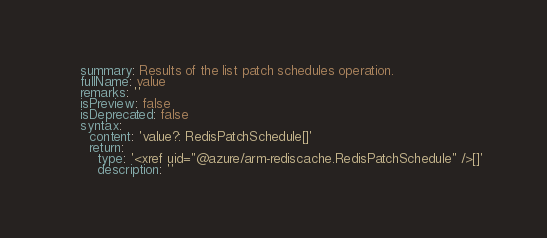Convert code to text. <code><loc_0><loc_0><loc_500><loc_500><_YAML_>    summary: Results of the list patch schedules operation.
    fullName: value
    remarks: ''
    isPreview: false
    isDeprecated: false
    syntax:
      content: 'value?: RedisPatchSchedule[]'
      return:
        type: '<xref uid="@azure/arm-rediscache.RedisPatchSchedule" />[]'
        description: ''
</code> 